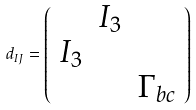Convert formula to latex. <formula><loc_0><loc_0><loc_500><loc_500>d _ { I J } = \left ( \begin{array} { r r r } & I _ { 3 } & \\ I _ { 3 } & & \\ & & \Gamma _ { b c } \end{array} \right )</formula> 